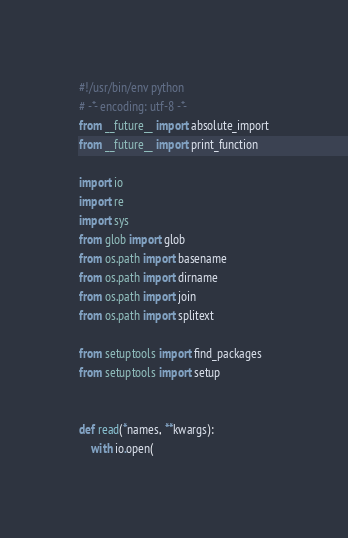Convert code to text. <code><loc_0><loc_0><loc_500><loc_500><_Python_>#!/usr/bin/env python
# -*- encoding: utf-8 -*-
from __future__ import absolute_import
from __future__ import print_function

import io
import re
import sys
from glob import glob
from os.path import basename
from os.path import dirname
from os.path import join
from os.path import splitext

from setuptools import find_packages
from setuptools import setup


def read(*names, **kwargs):
    with io.open(</code> 